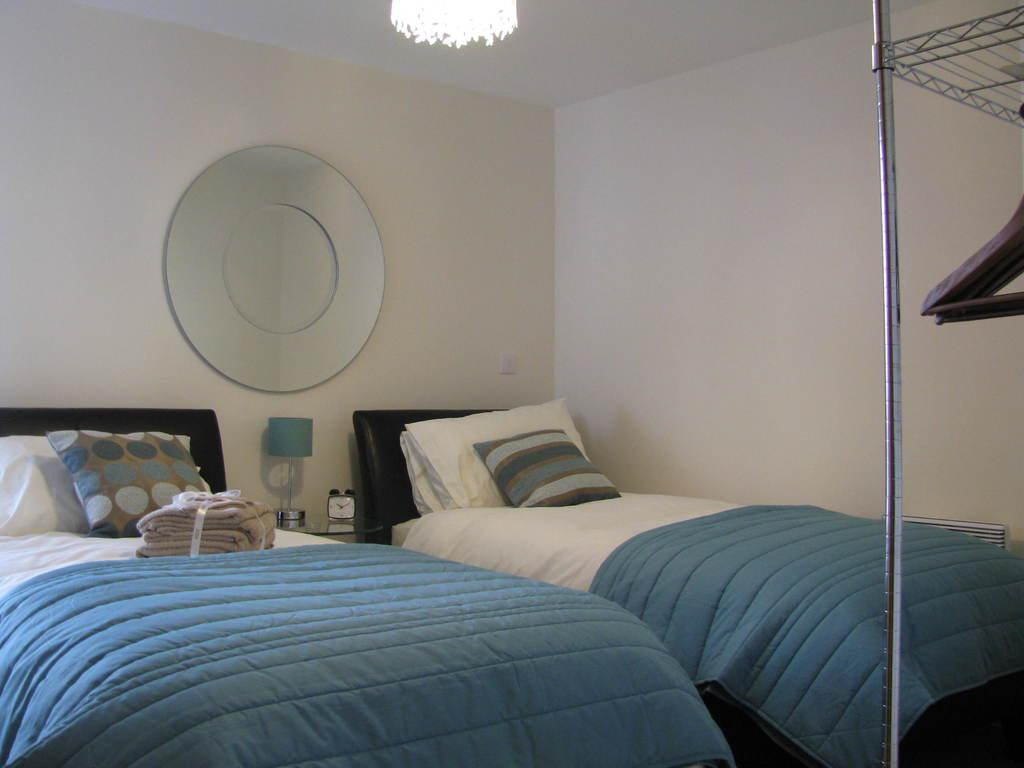How many beds are in the room? There are two beds in the room. What can be found on the beds? There are pillows on the beds. What is one of the features of the room? There is a wall in the room. What is a source of light in the room? There is a light in the room. What is another source of light in the room? There is a lamp in the room. What type of art can be seen on the voyage in the image? There is no voyage or art present in the image; it features a room with two beds, pillows, walls, lights, and a lamp. 